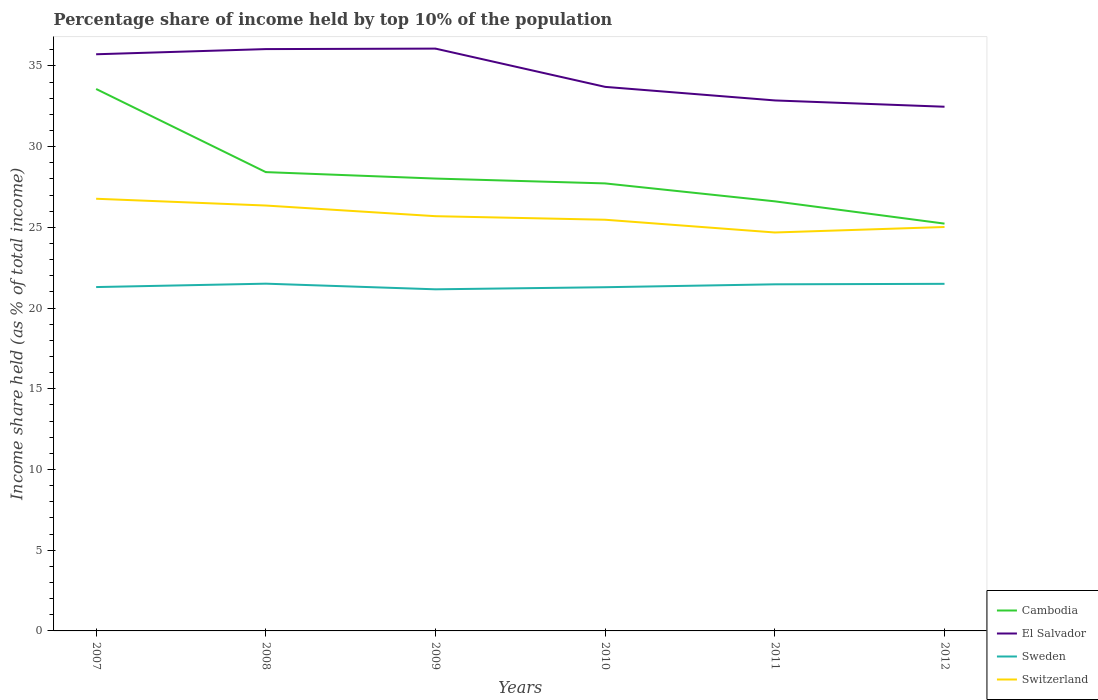Is the number of lines equal to the number of legend labels?
Keep it short and to the point. Yes. Across all years, what is the maximum percentage share of income held by top 10% of the population in Switzerland?
Offer a terse response. 24.68. What is the total percentage share of income held by top 10% of the population in El Salvador in the graph?
Your answer should be very brief. -0.32. What is the difference between the highest and the second highest percentage share of income held by top 10% of the population in El Salvador?
Your answer should be very brief. 3.6. Are the values on the major ticks of Y-axis written in scientific E-notation?
Ensure brevity in your answer.  No. Does the graph contain any zero values?
Give a very brief answer. No. Does the graph contain grids?
Offer a terse response. No. What is the title of the graph?
Your answer should be very brief. Percentage share of income held by top 10% of the population. Does "Peru" appear as one of the legend labels in the graph?
Provide a succinct answer. No. What is the label or title of the Y-axis?
Give a very brief answer. Income share held (as % of total income). What is the Income share held (as % of total income) in Cambodia in 2007?
Provide a short and direct response. 33.57. What is the Income share held (as % of total income) in El Salvador in 2007?
Offer a very short reply. 35.72. What is the Income share held (as % of total income) in Sweden in 2007?
Offer a terse response. 21.3. What is the Income share held (as % of total income) in Switzerland in 2007?
Your response must be concise. 26.77. What is the Income share held (as % of total income) of Cambodia in 2008?
Offer a terse response. 28.42. What is the Income share held (as % of total income) of El Salvador in 2008?
Make the answer very short. 36.04. What is the Income share held (as % of total income) of Sweden in 2008?
Make the answer very short. 21.51. What is the Income share held (as % of total income) in Switzerland in 2008?
Ensure brevity in your answer.  26.35. What is the Income share held (as % of total income) in Cambodia in 2009?
Provide a short and direct response. 28.02. What is the Income share held (as % of total income) of El Salvador in 2009?
Offer a terse response. 36.07. What is the Income share held (as % of total income) of Sweden in 2009?
Give a very brief answer. 21.16. What is the Income share held (as % of total income) of Switzerland in 2009?
Ensure brevity in your answer.  25.69. What is the Income share held (as % of total income) of Cambodia in 2010?
Offer a terse response. 27.72. What is the Income share held (as % of total income) in El Salvador in 2010?
Your answer should be very brief. 33.7. What is the Income share held (as % of total income) of Sweden in 2010?
Provide a succinct answer. 21.29. What is the Income share held (as % of total income) of Switzerland in 2010?
Provide a succinct answer. 25.47. What is the Income share held (as % of total income) of Cambodia in 2011?
Make the answer very short. 26.61. What is the Income share held (as % of total income) of El Salvador in 2011?
Your answer should be compact. 32.86. What is the Income share held (as % of total income) in Sweden in 2011?
Provide a succinct answer. 21.47. What is the Income share held (as % of total income) of Switzerland in 2011?
Offer a terse response. 24.68. What is the Income share held (as % of total income) in Cambodia in 2012?
Provide a succinct answer. 25.23. What is the Income share held (as % of total income) in El Salvador in 2012?
Provide a short and direct response. 32.47. What is the Income share held (as % of total income) of Switzerland in 2012?
Keep it short and to the point. 25.02. Across all years, what is the maximum Income share held (as % of total income) of Cambodia?
Offer a terse response. 33.57. Across all years, what is the maximum Income share held (as % of total income) in El Salvador?
Your answer should be very brief. 36.07. Across all years, what is the maximum Income share held (as % of total income) of Sweden?
Ensure brevity in your answer.  21.51. Across all years, what is the maximum Income share held (as % of total income) of Switzerland?
Keep it short and to the point. 26.77. Across all years, what is the minimum Income share held (as % of total income) in Cambodia?
Provide a succinct answer. 25.23. Across all years, what is the minimum Income share held (as % of total income) in El Salvador?
Offer a very short reply. 32.47. Across all years, what is the minimum Income share held (as % of total income) of Sweden?
Offer a very short reply. 21.16. Across all years, what is the minimum Income share held (as % of total income) of Switzerland?
Provide a succinct answer. 24.68. What is the total Income share held (as % of total income) of Cambodia in the graph?
Offer a very short reply. 169.57. What is the total Income share held (as % of total income) of El Salvador in the graph?
Ensure brevity in your answer.  206.86. What is the total Income share held (as % of total income) in Sweden in the graph?
Offer a terse response. 128.23. What is the total Income share held (as % of total income) in Switzerland in the graph?
Your response must be concise. 153.98. What is the difference between the Income share held (as % of total income) in Cambodia in 2007 and that in 2008?
Make the answer very short. 5.15. What is the difference between the Income share held (as % of total income) in El Salvador in 2007 and that in 2008?
Provide a short and direct response. -0.32. What is the difference between the Income share held (as % of total income) of Sweden in 2007 and that in 2008?
Your answer should be compact. -0.21. What is the difference between the Income share held (as % of total income) of Switzerland in 2007 and that in 2008?
Make the answer very short. 0.42. What is the difference between the Income share held (as % of total income) of Cambodia in 2007 and that in 2009?
Provide a succinct answer. 5.55. What is the difference between the Income share held (as % of total income) of El Salvador in 2007 and that in 2009?
Make the answer very short. -0.35. What is the difference between the Income share held (as % of total income) of Sweden in 2007 and that in 2009?
Provide a short and direct response. 0.14. What is the difference between the Income share held (as % of total income) of Cambodia in 2007 and that in 2010?
Keep it short and to the point. 5.85. What is the difference between the Income share held (as % of total income) in El Salvador in 2007 and that in 2010?
Provide a succinct answer. 2.02. What is the difference between the Income share held (as % of total income) of Sweden in 2007 and that in 2010?
Offer a very short reply. 0.01. What is the difference between the Income share held (as % of total income) of Switzerland in 2007 and that in 2010?
Ensure brevity in your answer.  1.3. What is the difference between the Income share held (as % of total income) of Cambodia in 2007 and that in 2011?
Provide a short and direct response. 6.96. What is the difference between the Income share held (as % of total income) of El Salvador in 2007 and that in 2011?
Keep it short and to the point. 2.86. What is the difference between the Income share held (as % of total income) in Sweden in 2007 and that in 2011?
Give a very brief answer. -0.17. What is the difference between the Income share held (as % of total income) in Switzerland in 2007 and that in 2011?
Offer a terse response. 2.09. What is the difference between the Income share held (as % of total income) of Cambodia in 2007 and that in 2012?
Your response must be concise. 8.34. What is the difference between the Income share held (as % of total income) in El Salvador in 2007 and that in 2012?
Your answer should be compact. 3.25. What is the difference between the Income share held (as % of total income) in Sweden in 2007 and that in 2012?
Offer a terse response. -0.2. What is the difference between the Income share held (as % of total income) of Cambodia in 2008 and that in 2009?
Your response must be concise. 0.4. What is the difference between the Income share held (as % of total income) in El Salvador in 2008 and that in 2009?
Offer a terse response. -0.03. What is the difference between the Income share held (as % of total income) in Sweden in 2008 and that in 2009?
Keep it short and to the point. 0.35. What is the difference between the Income share held (as % of total income) in Switzerland in 2008 and that in 2009?
Keep it short and to the point. 0.66. What is the difference between the Income share held (as % of total income) in El Salvador in 2008 and that in 2010?
Your answer should be compact. 2.34. What is the difference between the Income share held (as % of total income) in Sweden in 2008 and that in 2010?
Keep it short and to the point. 0.22. What is the difference between the Income share held (as % of total income) of Cambodia in 2008 and that in 2011?
Offer a terse response. 1.81. What is the difference between the Income share held (as % of total income) of El Salvador in 2008 and that in 2011?
Keep it short and to the point. 3.18. What is the difference between the Income share held (as % of total income) of Switzerland in 2008 and that in 2011?
Make the answer very short. 1.67. What is the difference between the Income share held (as % of total income) in Cambodia in 2008 and that in 2012?
Keep it short and to the point. 3.19. What is the difference between the Income share held (as % of total income) in El Salvador in 2008 and that in 2012?
Your response must be concise. 3.57. What is the difference between the Income share held (as % of total income) of Switzerland in 2008 and that in 2012?
Provide a short and direct response. 1.33. What is the difference between the Income share held (as % of total income) in Cambodia in 2009 and that in 2010?
Keep it short and to the point. 0.3. What is the difference between the Income share held (as % of total income) in El Salvador in 2009 and that in 2010?
Your answer should be very brief. 2.37. What is the difference between the Income share held (as % of total income) in Sweden in 2009 and that in 2010?
Your answer should be very brief. -0.13. What is the difference between the Income share held (as % of total income) of Switzerland in 2009 and that in 2010?
Your answer should be very brief. 0.22. What is the difference between the Income share held (as % of total income) of Cambodia in 2009 and that in 2011?
Offer a very short reply. 1.41. What is the difference between the Income share held (as % of total income) in El Salvador in 2009 and that in 2011?
Your answer should be compact. 3.21. What is the difference between the Income share held (as % of total income) of Sweden in 2009 and that in 2011?
Make the answer very short. -0.31. What is the difference between the Income share held (as % of total income) of Switzerland in 2009 and that in 2011?
Provide a succinct answer. 1.01. What is the difference between the Income share held (as % of total income) of Cambodia in 2009 and that in 2012?
Make the answer very short. 2.79. What is the difference between the Income share held (as % of total income) in El Salvador in 2009 and that in 2012?
Your answer should be compact. 3.6. What is the difference between the Income share held (as % of total income) in Sweden in 2009 and that in 2012?
Ensure brevity in your answer.  -0.34. What is the difference between the Income share held (as % of total income) of Switzerland in 2009 and that in 2012?
Offer a terse response. 0.67. What is the difference between the Income share held (as % of total income) in Cambodia in 2010 and that in 2011?
Your response must be concise. 1.11. What is the difference between the Income share held (as % of total income) in El Salvador in 2010 and that in 2011?
Give a very brief answer. 0.84. What is the difference between the Income share held (as % of total income) in Sweden in 2010 and that in 2011?
Give a very brief answer. -0.18. What is the difference between the Income share held (as % of total income) in Switzerland in 2010 and that in 2011?
Offer a terse response. 0.79. What is the difference between the Income share held (as % of total income) in Cambodia in 2010 and that in 2012?
Offer a terse response. 2.49. What is the difference between the Income share held (as % of total income) of El Salvador in 2010 and that in 2012?
Your response must be concise. 1.23. What is the difference between the Income share held (as % of total income) in Sweden in 2010 and that in 2012?
Offer a terse response. -0.21. What is the difference between the Income share held (as % of total income) of Switzerland in 2010 and that in 2012?
Your response must be concise. 0.45. What is the difference between the Income share held (as % of total income) of Cambodia in 2011 and that in 2012?
Keep it short and to the point. 1.38. What is the difference between the Income share held (as % of total income) in El Salvador in 2011 and that in 2012?
Keep it short and to the point. 0.39. What is the difference between the Income share held (as % of total income) in Sweden in 2011 and that in 2012?
Your response must be concise. -0.03. What is the difference between the Income share held (as % of total income) of Switzerland in 2011 and that in 2012?
Your response must be concise. -0.34. What is the difference between the Income share held (as % of total income) of Cambodia in 2007 and the Income share held (as % of total income) of El Salvador in 2008?
Your answer should be very brief. -2.47. What is the difference between the Income share held (as % of total income) of Cambodia in 2007 and the Income share held (as % of total income) of Sweden in 2008?
Provide a succinct answer. 12.06. What is the difference between the Income share held (as % of total income) of Cambodia in 2007 and the Income share held (as % of total income) of Switzerland in 2008?
Ensure brevity in your answer.  7.22. What is the difference between the Income share held (as % of total income) in El Salvador in 2007 and the Income share held (as % of total income) in Sweden in 2008?
Offer a terse response. 14.21. What is the difference between the Income share held (as % of total income) of El Salvador in 2007 and the Income share held (as % of total income) of Switzerland in 2008?
Make the answer very short. 9.37. What is the difference between the Income share held (as % of total income) of Sweden in 2007 and the Income share held (as % of total income) of Switzerland in 2008?
Offer a very short reply. -5.05. What is the difference between the Income share held (as % of total income) of Cambodia in 2007 and the Income share held (as % of total income) of Sweden in 2009?
Your answer should be compact. 12.41. What is the difference between the Income share held (as % of total income) in Cambodia in 2007 and the Income share held (as % of total income) in Switzerland in 2009?
Ensure brevity in your answer.  7.88. What is the difference between the Income share held (as % of total income) in El Salvador in 2007 and the Income share held (as % of total income) in Sweden in 2009?
Provide a succinct answer. 14.56. What is the difference between the Income share held (as % of total income) in El Salvador in 2007 and the Income share held (as % of total income) in Switzerland in 2009?
Offer a terse response. 10.03. What is the difference between the Income share held (as % of total income) in Sweden in 2007 and the Income share held (as % of total income) in Switzerland in 2009?
Your answer should be compact. -4.39. What is the difference between the Income share held (as % of total income) of Cambodia in 2007 and the Income share held (as % of total income) of El Salvador in 2010?
Give a very brief answer. -0.13. What is the difference between the Income share held (as % of total income) in Cambodia in 2007 and the Income share held (as % of total income) in Sweden in 2010?
Your answer should be very brief. 12.28. What is the difference between the Income share held (as % of total income) of Cambodia in 2007 and the Income share held (as % of total income) of Switzerland in 2010?
Your answer should be very brief. 8.1. What is the difference between the Income share held (as % of total income) of El Salvador in 2007 and the Income share held (as % of total income) of Sweden in 2010?
Provide a short and direct response. 14.43. What is the difference between the Income share held (as % of total income) of El Salvador in 2007 and the Income share held (as % of total income) of Switzerland in 2010?
Your answer should be compact. 10.25. What is the difference between the Income share held (as % of total income) of Sweden in 2007 and the Income share held (as % of total income) of Switzerland in 2010?
Provide a succinct answer. -4.17. What is the difference between the Income share held (as % of total income) in Cambodia in 2007 and the Income share held (as % of total income) in El Salvador in 2011?
Offer a terse response. 0.71. What is the difference between the Income share held (as % of total income) of Cambodia in 2007 and the Income share held (as % of total income) of Switzerland in 2011?
Your response must be concise. 8.89. What is the difference between the Income share held (as % of total income) in El Salvador in 2007 and the Income share held (as % of total income) in Sweden in 2011?
Provide a short and direct response. 14.25. What is the difference between the Income share held (as % of total income) in El Salvador in 2007 and the Income share held (as % of total income) in Switzerland in 2011?
Provide a succinct answer. 11.04. What is the difference between the Income share held (as % of total income) in Sweden in 2007 and the Income share held (as % of total income) in Switzerland in 2011?
Offer a very short reply. -3.38. What is the difference between the Income share held (as % of total income) of Cambodia in 2007 and the Income share held (as % of total income) of Sweden in 2012?
Offer a terse response. 12.07. What is the difference between the Income share held (as % of total income) in Cambodia in 2007 and the Income share held (as % of total income) in Switzerland in 2012?
Offer a terse response. 8.55. What is the difference between the Income share held (as % of total income) in El Salvador in 2007 and the Income share held (as % of total income) in Sweden in 2012?
Give a very brief answer. 14.22. What is the difference between the Income share held (as % of total income) of Sweden in 2007 and the Income share held (as % of total income) of Switzerland in 2012?
Provide a short and direct response. -3.72. What is the difference between the Income share held (as % of total income) of Cambodia in 2008 and the Income share held (as % of total income) of El Salvador in 2009?
Provide a short and direct response. -7.65. What is the difference between the Income share held (as % of total income) of Cambodia in 2008 and the Income share held (as % of total income) of Sweden in 2009?
Keep it short and to the point. 7.26. What is the difference between the Income share held (as % of total income) of Cambodia in 2008 and the Income share held (as % of total income) of Switzerland in 2009?
Keep it short and to the point. 2.73. What is the difference between the Income share held (as % of total income) in El Salvador in 2008 and the Income share held (as % of total income) in Sweden in 2009?
Make the answer very short. 14.88. What is the difference between the Income share held (as % of total income) of El Salvador in 2008 and the Income share held (as % of total income) of Switzerland in 2009?
Offer a terse response. 10.35. What is the difference between the Income share held (as % of total income) in Sweden in 2008 and the Income share held (as % of total income) in Switzerland in 2009?
Your answer should be very brief. -4.18. What is the difference between the Income share held (as % of total income) of Cambodia in 2008 and the Income share held (as % of total income) of El Salvador in 2010?
Provide a succinct answer. -5.28. What is the difference between the Income share held (as % of total income) in Cambodia in 2008 and the Income share held (as % of total income) in Sweden in 2010?
Offer a terse response. 7.13. What is the difference between the Income share held (as % of total income) in Cambodia in 2008 and the Income share held (as % of total income) in Switzerland in 2010?
Your answer should be very brief. 2.95. What is the difference between the Income share held (as % of total income) of El Salvador in 2008 and the Income share held (as % of total income) of Sweden in 2010?
Offer a very short reply. 14.75. What is the difference between the Income share held (as % of total income) in El Salvador in 2008 and the Income share held (as % of total income) in Switzerland in 2010?
Make the answer very short. 10.57. What is the difference between the Income share held (as % of total income) in Sweden in 2008 and the Income share held (as % of total income) in Switzerland in 2010?
Keep it short and to the point. -3.96. What is the difference between the Income share held (as % of total income) in Cambodia in 2008 and the Income share held (as % of total income) in El Salvador in 2011?
Make the answer very short. -4.44. What is the difference between the Income share held (as % of total income) of Cambodia in 2008 and the Income share held (as % of total income) of Sweden in 2011?
Your answer should be compact. 6.95. What is the difference between the Income share held (as % of total income) of Cambodia in 2008 and the Income share held (as % of total income) of Switzerland in 2011?
Provide a short and direct response. 3.74. What is the difference between the Income share held (as % of total income) in El Salvador in 2008 and the Income share held (as % of total income) in Sweden in 2011?
Your answer should be compact. 14.57. What is the difference between the Income share held (as % of total income) in El Salvador in 2008 and the Income share held (as % of total income) in Switzerland in 2011?
Provide a succinct answer. 11.36. What is the difference between the Income share held (as % of total income) of Sweden in 2008 and the Income share held (as % of total income) of Switzerland in 2011?
Your answer should be compact. -3.17. What is the difference between the Income share held (as % of total income) of Cambodia in 2008 and the Income share held (as % of total income) of El Salvador in 2012?
Provide a short and direct response. -4.05. What is the difference between the Income share held (as % of total income) of Cambodia in 2008 and the Income share held (as % of total income) of Sweden in 2012?
Keep it short and to the point. 6.92. What is the difference between the Income share held (as % of total income) in Cambodia in 2008 and the Income share held (as % of total income) in Switzerland in 2012?
Your answer should be very brief. 3.4. What is the difference between the Income share held (as % of total income) in El Salvador in 2008 and the Income share held (as % of total income) in Sweden in 2012?
Make the answer very short. 14.54. What is the difference between the Income share held (as % of total income) in El Salvador in 2008 and the Income share held (as % of total income) in Switzerland in 2012?
Make the answer very short. 11.02. What is the difference between the Income share held (as % of total income) in Sweden in 2008 and the Income share held (as % of total income) in Switzerland in 2012?
Give a very brief answer. -3.51. What is the difference between the Income share held (as % of total income) in Cambodia in 2009 and the Income share held (as % of total income) in El Salvador in 2010?
Offer a terse response. -5.68. What is the difference between the Income share held (as % of total income) in Cambodia in 2009 and the Income share held (as % of total income) in Sweden in 2010?
Give a very brief answer. 6.73. What is the difference between the Income share held (as % of total income) of Cambodia in 2009 and the Income share held (as % of total income) of Switzerland in 2010?
Your answer should be compact. 2.55. What is the difference between the Income share held (as % of total income) of El Salvador in 2009 and the Income share held (as % of total income) of Sweden in 2010?
Provide a succinct answer. 14.78. What is the difference between the Income share held (as % of total income) in Sweden in 2009 and the Income share held (as % of total income) in Switzerland in 2010?
Keep it short and to the point. -4.31. What is the difference between the Income share held (as % of total income) in Cambodia in 2009 and the Income share held (as % of total income) in El Salvador in 2011?
Your answer should be compact. -4.84. What is the difference between the Income share held (as % of total income) of Cambodia in 2009 and the Income share held (as % of total income) of Sweden in 2011?
Your answer should be compact. 6.55. What is the difference between the Income share held (as % of total income) in Cambodia in 2009 and the Income share held (as % of total income) in Switzerland in 2011?
Offer a terse response. 3.34. What is the difference between the Income share held (as % of total income) of El Salvador in 2009 and the Income share held (as % of total income) of Switzerland in 2011?
Ensure brevity in your answer.  11.39. What is the difference between the Income share held (as % of total income) in Sweden in 2009 and the Income share held (as % of total income) in Switzerland in 2011?
Your response must be concise. -3.52. What is the difference between the Income share held (as % of total income) in Cambodia in 2009 and the Income share held (as % of total income) in El Salvador in 2012?
Provide a succinct answer. -4.45. What is the difference between the Income share held (as % of total income) of Cambodia in 2009 and the Income share held (as % of total income) of Sweden in 2012?
Keep it short and to the point. 6.52. What is the difference between the Income share held (as % of total income) of El Salvador in 2009 and the Income share held (as % of total income) of Sweden in 2012?
Make the answer very short. 14.57. What is the difference between the Income share held (as % of total income) of El Salvador in 2009 and the Income share held (as % of total income) of Switzerland in 2012?
Provide a short and direct response. 11.05. What is the difference between the Income share held (as % of total income) in Sweden in 2009 and the Income share held (as % of total income) in Switzerland in 2012?
Keep it short and to the point. -3.86. What is the difference between the Income share held (as % of total income) of Cambodia in 2010 and the Income share held (as % of total income) of El Salvador in 2011?
Keep it short and to the point. -5.14. What is the difference between the Income share held (as % of total income) of Cambodia in 2010 and the Income share held (as % of total income) of Sweden in 2011?
Make the answer very short. 6.25. What is the difference between the Income share held (as % of total income) of Cambodia in 2010 and the Income share held (as % of total income) of Switzerland in 2011?
Provide a succinct answer. 3.04. What is the difference between the Income share held (as % of total income) in El Salvador in 2010 and the Income share held (as % of total income) in Sweden in 2011?
Your response must be concise. 12.23. What is the difference between the Income share held (as % of total income) of El Salvador in 2010 and the Income share held (as % of total income) of Switzerland in 2011?
Your answer should be compact. 9.02. What is the difference between the Income share held (as % of total income) in Sweden in 2010 and the Income share held (as % of total income) in Switzerland in 2011?
Provide a succinct answer. -3.39. What is the difference between the Income share held (as % of total income) of Cambodia in 2010 and the Income share held (as % of total income) of El Salvador in 2012?
Offer a very short reply. -4.75. What is the difference between the Income share held (as % of total income) in Cambodia in 2010 and the Income share held (as % of total income) in Sweden in 2012?
Your response must be concise. 6.22. What is the difference between the Income share held (as % of total income) in Cambodia in 2010 and the Income share held (as % of total income) in Switzerland in 2012?
Ensure brevity in your answer.  2.7. What is the difference between the Income share held (as % of total income) in El Salvador in 2010 and the Income share held (as % of total income) in Switzerland in 2012?
Ensure brevity in your answer.  8.68. What is the difference between the Income share held (as % of total income) in Sweden in 2010 and the Income share held (as % of total income) in Switzerland in 2012?
Your response must be concise. -3.73. What is the difference between the Income share held (as % of total income) of Cambodia in 2011 and the Income share held (as % of total income) of El Salvador in 2012?
Give a very brief answer. -5.86. What is the difference between the Income share held (as % of total income) of Cambodia in 2011 and the Income share held (as % of total income) of Sweden in 2012?
Provide a succinct answer. 5.11. What is the difference between the Income share held (as % of total income) in Cambodia in 2011 and the Income share held (as % of total income) in Switzerland in 2012?
Make the answer very short. 1.59. What is the difference between the Income share held (as % of total income) in El Salvador in 2011 and the Income share held (as % of total income) in Sweden in 2012?
Make the answer very short. 11.36. What is the difference between the Income share held (as % of total income) in El Salvador in 2011 and the Income share held (as % of total income) in Switzerland in 2012?
Offer a very short reply. 7.84. What is the difference between the Income share held (as % of total income) of Sweden in 2011 and the Income share held (as % of total income) of Switzerland in 2012?
Give a very brief answer. -3.55. What is the average Income share held (as % of total income) in Cambodia per year?
Provide a succinct answer. 28.26. What is the average Income share held (as % of total income) of El Salvador per year?
Your response must be concise. 34.48. What is the average Income share held (as % of total income) in Sweden per year?
Give a very brief answer. 21.37. What is the average Income share held (as % of total income) of Switzerland per year?
Your answer should be compact. 25.66. In the year 2007, what is the difference between the Income share held (as % of total income) of Cambodia and Income share held (as % of total income) of El Salvador?
Your answer should be very brief. -2.15. In the year 2007, what is the difference between the Income share held (as % of total income) of Cambodia and Income share held (as % of total income) of Sweden?
Give a very brief answer. 12.27. In the year 2007, what is the difference between the Income share held (as % of total income) in El Salvador and Income share held (as % of total income) in Sweden?
Your answer should be compact. 14.42. In the year 2007, what is the difference between the Income share held (as % of total income) of El Salvador and Income share held (as % of total income) of Switzerland?
Provide a short and direct response. 8.95. In the year 2007, what is the difference between the Income share held (as % of total income) of Sweden and Income share held (as % of total income) of Switzerland?
Give a very brief answer. -5.47. In the year 2008, what is the difference between the Income share held (as % of total income) in Cambodia and Income share held (as % of total income) in El Salvador?
Provide a short and direct response. -7.62. In the year 2008, what is the difference between the Income share held (as % of total income) of Cambodia and Income share held (as % of total income) of Sweden?
Keep it short and to the point. 6.91. In the year 2008, what is the difference between the Income share held (as % of total income) of Cambodia and Income share held (as % of total income) of Switzerland?
Provide a succinct answer. 2.07. In the year 2008, what is the difference between the Income share held (as % of total income) in El Salvador and Income share held (as % of total income) in Sweden?
Give a very brief answer. 14.53. In the year 2008, what is the difference between the Income share held (as % of total income) of El Salvador and Income share held (as % of total income) of Switzerland?
Keep it short and to the point. 9.69. In the year 2008, what is the difference between the Income share held (as % of total income) in Sweden and Income share held (as % of total income) in Switzerland?
Keep it short and to the point. -4.84. In the year 2009, what is the difference between the Income share held (as % of total income) in Cambodia and Income share held (as % of total income) in El Salvador?
Your answer should be compact. -8.05. In the year 2009, what is the difference between the Income share held (as % of total income) in Cambodia and Income share held (as % of total income) in Sweden?
Offer a terse response. 6.86. In the year 2009, what is the difference between the Income share held (as % of total income) in Cambodia and Income share held (as % of total income) in Switzerland?
Provide a succinct answer. 2.33. In the year 2009, what is the difference between the Income share held (as % of total income) in El Salvador and Income share held (as % of total income) in Sweden?
Provide a succinct answer. 14.91. In the year 2009, what is the difference between the Income share held (as % of total income) of El Salvador and Income share held (as % of total income) of Switzerland?
Make the answer very short. 10.38. In the year 2009, what is the difference between the Income share held (as % of total income) in Sweden and Income share held (as % of total income) in Switzerland?
Your answer should be compact. -4.53. In the year 2010, what is the difference between the Income share held (as % of total income) of Cambodia and Income share held (as % of total income) of El Salvador?
Provide a succinct answer. -5.98. In the year 2010, what is the difference between the Income share held (as % of total income) of Cambodia and Income share held (as % of total income) of Sweden?
Your answer should be very brief. 6.43. In the year 2010, what is the difference between the Income share held (as % of total income) in Cambodia and Income share held (as % of total income) in Switzerland?
Provide a short and direct response. 2.25. In the year 2010, what is the difference between the Income share held (as % of total income) of El Salvador and Income share held (as % of total income) of Sweden?
Offer a very short reply. 12.41. In the year 2010, what is the difference between the Income share held (as % of total income) in El Salvador and Income share held (as % of total income) in Switzerland?
Provide a succinct answer. 8.23. In the year 2010, what is the difference between the Income share held (as % of total income) of Sweden and Income share held (as % of total income) of Switzerland?
Offer a terse response. -4.18. In the year 2011, what is the difference between the Income share held (as % of total income) in Cambodia and Income share held (as % of total income) in El Salvador?
Your answer should be very brief. -6.25. In the year 2011, what is the difference between the Income share held (as % of total income) of Cambodia and Income share held (as % of total income) of Sweden?
Your answer should be very brief. 5.14. In the year 2011, what is the difference between the Income share held (as % of total income) in Cambodia and Income share held (as % of total income) in Switzerland?
Offer a very short reply. 1.93. In the year 2011, what is the difference between the Income share held (as % of total income) in El Salvador and Income share held (as % of total income) in Sweden?
Make the answer very short. 11.39. In the year 2011, what is the difference between the Income share held (as % of total income) in El Salvador and Income share held (as % of total income) in Switzerland?
Provide a short and direct response. 8.18. In the year 2011, what is the difference between the Income share held (as % of total income) of Sweden and Income share held (as % of total income) of Switzerland?
Make the answer very short. -3.21. In the year 2012, what is the difference between the Income share held (as % of total income) in Cambodia and Income share held (as % of total income) in El Salvador?
Your answer should be compact. -7.24. In the year 2012, what is the difference between the Income share held (as % of total income) of Cambodia and Income share held (as % of total income) of Sweden?
Make the answer very short. 3.73. In the year 2012, what is the difference between the Income share held (as % of total income) in Cambodia and Income share held (as % of total income) in Switzerland?
Your answer should be compact. 0.21. In the year 2012, what is the difference between the Income share held (as % of total income) in El Salvador and Income share held (as % of total income) in Sweden?
Provide a succinct answer. 10.97. In the year 2012, what is the difference between the Income share held (as % of total income) of El Salvador and Income share held (as % of total income) of Switzerland?
Your answer should be very brief. 7.45. In the year 2012, what is the difference between the Income share held (as % of total income) in Sweden and Income share held (as % of total income) in Switzerland?
Provide a succinct answer. -3.52. What is the ratio of the Income share held (as % of total income) in Cambodia in 2007 to that in 2008?
Your response must be concise. 1.18. What is the ratio of the Income share held (as % of total income) of El Salvador in 2007 to that in 2008?
Your answer should be compact. 0.99. What is the ratio of the Income share held (as % of total income) of Sweden in 2007 to that in 2008?
Provide a succinct answer. 0.99. What is the ratio of the Income share held (as % of total income) of Switzerland in 2007 to that in 2008?
Offer a terse response. 1.02. What is the ratio of the Income share held (as % of total income) of Cambodia in 2007 to that in 2009?
Offer a terse response. 1.2. What is the ratio of the Income share held (as % of total income) in El Salvador in 2007 to that in 2009?
Offer a terse response. 0.99. What is the ratio of the Income share held (as % of total income) in Sweden in 2007 to that in 2009?
Provide a short and direct response. 1.01. What is the ratio of the Income share held (as % of total income) of Switzerland in 2007 to that in 2009?
Keep it short and to the point. 1.04. What is the ratio of the Income share held (as % of total income) of Cambodia in 2007 to that in 2010?
Provide a short and direct response. 1.21. What is the ratio of the Income share held (as % of total income) in El Salvador in 2007 to that in 2010?
Your response must be concise. 1.06. What is the ratio of the Income share held (as % of total income) of Switzerland in 2007 to that in 2010?
Keep it short and to the point. 1.05. What is the ratio of the Income share held (as % of total income) in Cambodia in 2007 to that in 2011?
Ensure brevity in your answer.  1.26. What is the ratio of the Income share held (as % of total income) of El Salvador in 2007 to that in 2011?
Provide a succinct answer. 1.09. What is the ratio of the Income share held (as % of total income) of Switzerland in 2007 to that in 2011?
Provide a short and direct response. 1.08. What is the ratio of the Income share held (as % of total income) in Cambodia in 2007 to that in 2012?
Your answer should be compact. 1.33. What is the ratio of the Income share held (as % of total income) in El Salvador in 2007 to that in 2012?
Your answer should be very brief. 1.1. What is the ratio of the Income share held (as % of total income) in Sweden in 2007 to that in 2012?
Provide a short and direct response. 0.99. What is the ratio of the Income share held (as % of total income) in Switzerland in 2007 to that in 2012?
Provide a succinct answer. 1.07. What is the ratio of the Income share held (as % of total income) of Cambodia in 2008 to that in 2009?
Provide a succinct answer. 1.01. What is the ratio of the Income share held (as % of total income) in Sweden in 2008 to that in 2009?
Ensure brevity in your answer.  1.02. What is the ratio of the Income share held (as % of total income) of Switzerland in 2008 to that in 2009?
Make the answer very short. 1.03. What is the ratio of the Income share held (as % of total income) in Cambodia in 2008 to that in 2010?
Your answer should be compact. 1.03. What is the ratio of the Income share held (as % of total income) in El Salvador in 2008 to that in 2010?
Your answer should be compact. 1.07. What is the ratio of the Income share held (as % of total income) of Sweden in 2008 to that in 2010?
Offer a terse response. 1.01. What is the ratio of the Income share held (as % of total income) of Switzerland in 2008 to that in 2010?
Offer a terse response. 1.03. What is the ratio of the Income share held (as % of total income) of Cambodia in 2008 to that in 2011?
Keep it short and to the point. 1.07. What is the ratio of the Income share held (as % of total income) in El Salvador in 2008 to that in 2011?
Make the answer very short. 1.1. What is the ratio of the Income share held (as % of total income) of Switzerland in 2008 to that in 2011?
Offer a very short reply. 1.07. What is the ratio of the Income share held (as % of total income) in Cambodia in 2008 to that in 2012?
Offer a very short reply. 1.13. What is the ratio of the Income share held (as % of total income) of El Salvador in 2008 to that in 2012?
Ensure brevity in your answer.  1.11. What is the ratio of the Income share held (as % of total income) in Sweden in 2008 to that in 2012?
Make the answer very short. 1. What is the ratio of the Income share held (as % of total income) in Switzerland in 2008 to that in 2012?
Your answer should be very brief. 1.05. What is the ratio of the Income share held (as % of total income) in Cambodia in 2009 to that in 2010?
Make the answer very short. 1.01. What is the ratio of the Income share held (as % of total income) of El Salvador in 2009 to that in 2010?
Keep it short and to the point. 1.07. What is the ratio of the Income share held (as % of total income) in Sweden in 2009 to that in 2010?
Your answer should be compact. 0.99. What is the ratio of the Income share held (as % of total income) of Switzerland in 2009 to that in 2010?
Your response must be concise. 1.01. What is the ratio of the Income share held (as % of total income) in Cambodia in 2009 to that in 2011?
Your response must be concise. 1.05. What is the ratio of the Income share held (as % of total income) in El Salvador in 2009 to that in 2011?
Offer a terse response. 1.1. What is the ratio of the Income share held (as % of total income) in Sweden in 2009 to that in 2011?
Ensure brevity in your answer.  0.99. What is the ratio of the Income share held (as % of total income) of Switzerland in 2009 to that in 2011?
Offer a terse response. 1.04. What is the ratio of the Income share held (as % of total income) in Cambodia in 2009 to that in 2012?
Your answer should be compact. 1.11. What is the ratio of the Income share held (as % of total income) in El Salvador in 2009 to that in 2012?
Provide a succinct answer. 1.11. What is the ratio of the Income share held (as % of total income) in Sweden in 2009 to that in 2012?
Your response must be concise. 0.98. What is the ratio of the Income share held (as % of total income) of Switzerland in 2009 to that in 2012?
Provide a succinct answer. 1.03. What is the ratio of the Income share held (as % of total income) in Cambodia in 2010 to that in 2011?
Make the answer very short. 1.04. What is the ratio of the Income share held (as % of total income) of El Salvador in 2010 to that in 2011?
Give a very brief answer. 1.03. What is the ratio of the Income share held (as % of total income) of Sweden in 2010 to that in 2011?
Your answer should be compact. 0.99. What is the ratio of the Income share held (as % of total income) of Switzerland in 2010 to that in 2011?
Offer a terse response. 1.03. What is the ratio of the Income share held (as % of total income) of Cambodia in 2010 to that in 2012?
Give a very brief answer. 1.1. What is the ratio of the Income share held (as % of total income) of El Salvador in 2010 to that in 2012?
Offer a very short reply. 1.04. What is the ratio of the Income share held (as % of total income) in Sweden in 2010 to that in 2012?
Your response must be concise. 0.99. What is the ratio of the Income share held (as % of total income) of Switzerland in 2010 to that in 2012?
Offer a very short reply. 1.02. What is the ratio of the Income share held (as % of total income) of Cambodia in 2011 to that in 2012?
Offer a terse response. 1.05. What is the ratio of the Income share held (as % of total income) in El Salvador in 2011 to that in 2012?
Offer a terse response. 1.01. What is the ratio of the Income share held (as % of total income) in Sweden in 2011 to that in 2012?
Your answer should be very brief. 1. What is the ratio of the Income share held (as % of total income) of Switzerland in 2011 to that in 2012?
Give a very brief answer. 0.99. What is the difference between the highest and the second highest Income share held (as % of total income) of Cambodia?
Your response must be concise. 5.15. What is the difference between the highest and the second highest Income share held (as % of total income) in El Salvador?
Your response must be concise. 0.03. What is the difference between the highest and the second highest Income share held (as % of total income) in Switzerland?
Keep it short and to the point. 0.42. What is the difference between the highest and the lowest Income share held (as % of total income) in Cambodia?
Your answer should be compact. 8.34. What is the difference between the highest and the lowest Income share held (as % of total income) of El Salvador?
Offer a very short reply. 3.6. What is the difference between the highest and the lowest Income share held (as % of total income) of Switzerland?
Offer a very short reply. 2.09. 